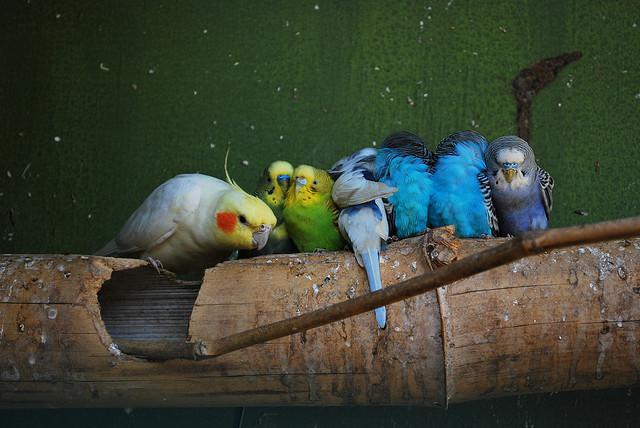What type of bird is the one on the far left?

Choices:
A) toucan
B) cockatiel
C) parrot
D) dove cockatiel 